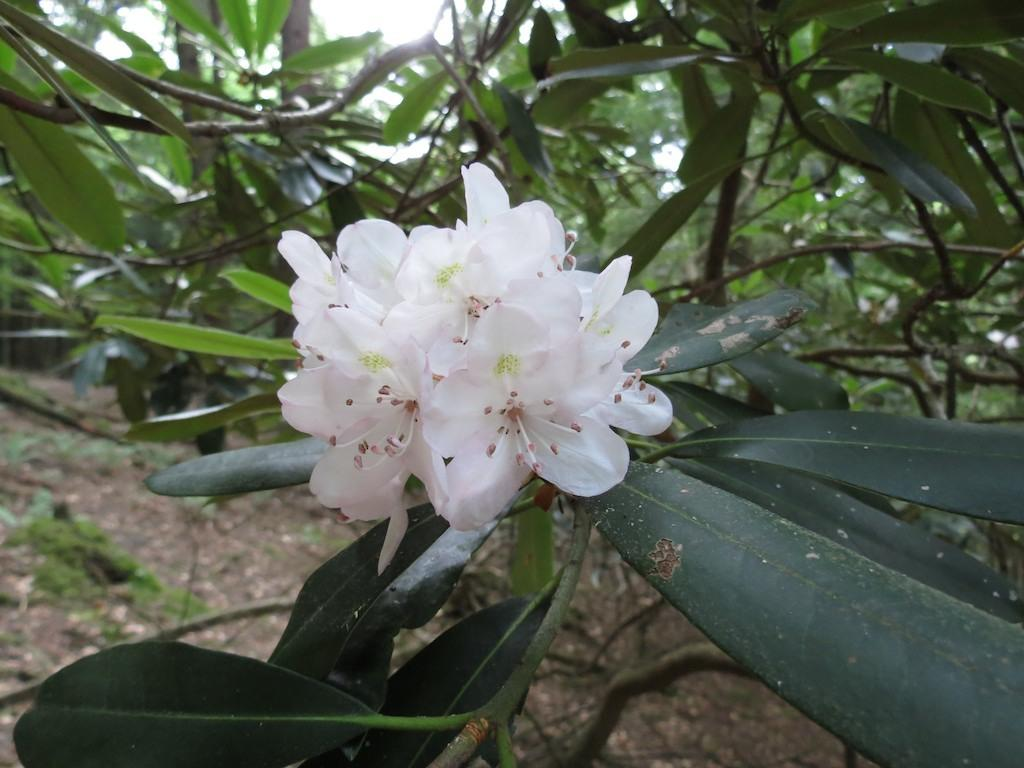What type of flowers are in the image? There are white flowers in the image. What part of the flowers can be seen connecting them to the plant? The flowers have stems. What can be seen in the background of the image? There is a plant in the background of the image. What type of vegetation is visible in the image? Grass is visible in the image. What substance is present on the floor in the image? Soil is present on the floor in the image. How many women are holding grapes in the image? There are no women or grapes present in the image. What type of branch can be seen extending from the flowers in the image? There is no branch extending from the flowers in the image; only the stems are visible. 